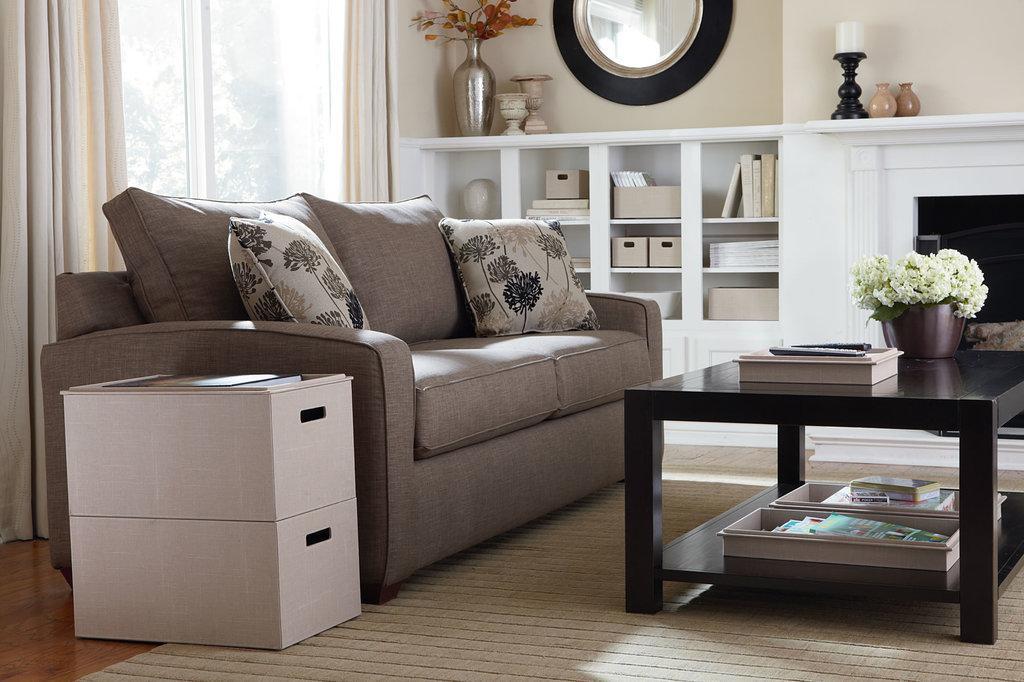Can you describe this image briefly? in this image there is a table at the right side which consists of flower pot on it. left to that is a sofa which consists of two cushions. behind the sofa there's a window which contains cream curtains. at the right side there is a mirror fixed to it and shelves at the down. 